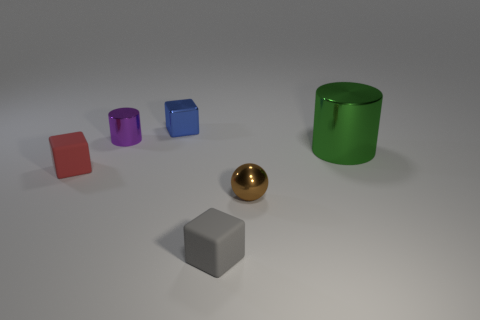Does the big thing have the same color as the tiny metallic block?
Provide a short and direct response. No. The thing that is in front of the purple shiny object and on the left side of the blue metal block is made of what material?
Your response must be concise. Rubber. The green metal thing has what size?
Your answer should be compact. Large. There is a small rubber cube behind the rubber block that is in front of the tiny red block; how many gray rubber things are on the right side of it?
Provide a short and direct response. 1. What is the shape of the small thing on the right side of the small rubber object that is right of the small red object?
Make the answer very short. Sphere. The other purple thing that is the same shape as the large thing is what size?
Your response must be concise. Small. Is there any other thing that is the same size as the blue object?
Your answer should be compact. Yes. What color is the block left of the tiny blue block?
Ensure brevity in your answer.  Red. There is a block in front of the small rubber object to the left of the metallic cylinder that is behind the large green thing; what is its material?
Give a very brief answer. Rubber. How big is the brown ball to the right of the cylinder that is to the left of the tiny brown object?
Give a very brief answer. Small. 